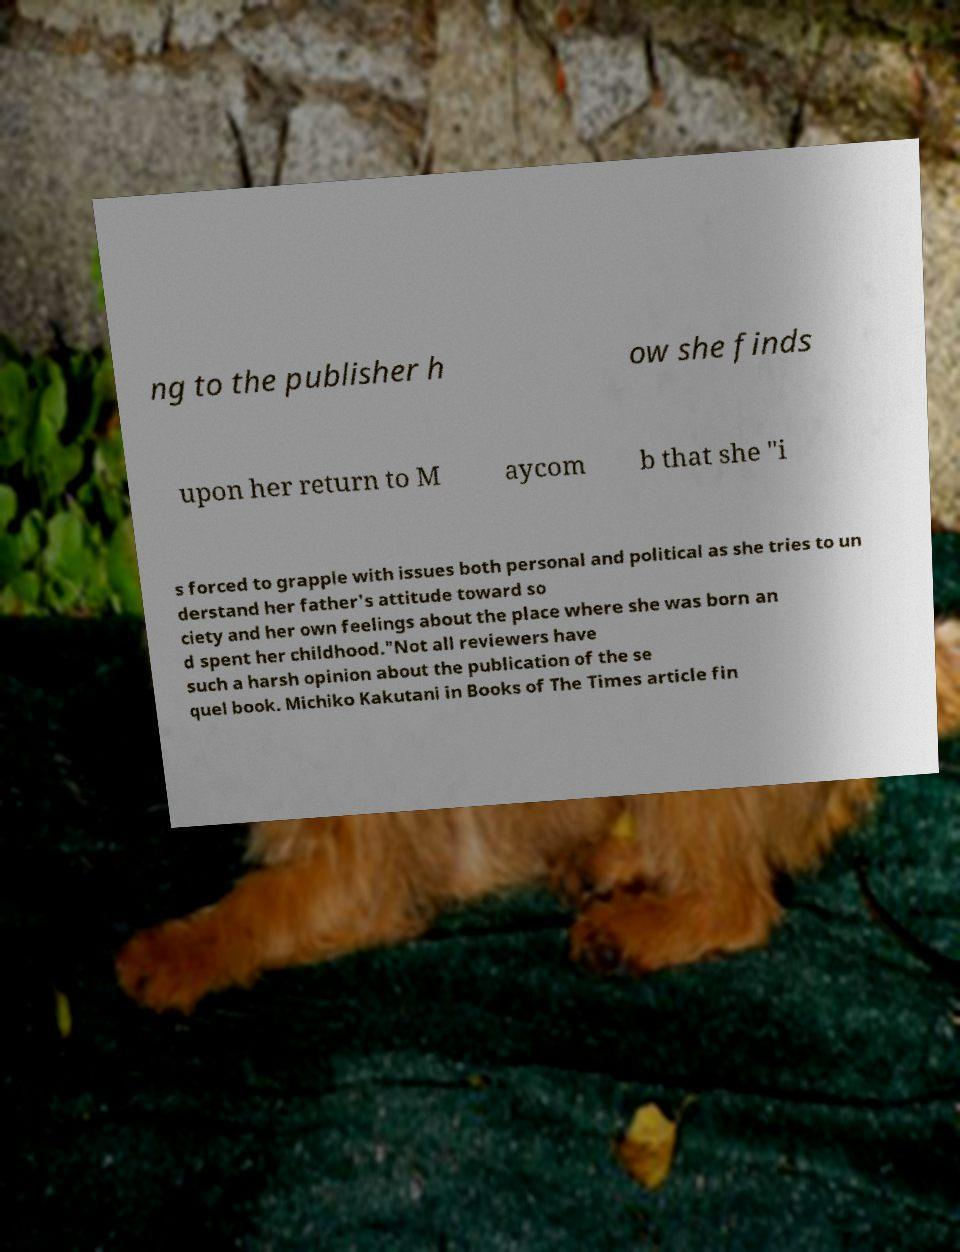I need the written content from this picture converted into text. Can you do that? ng to the publisher h ow she finds upon her return to M aycom b that she "i s forced to grapple with issues both personal and political as she tries to un derstand her father's attitude toward so ciety and her own feelings about the place where she was born an d spent her childhood."Not all reviewers have such a harsh opinion about the publication of the se quel book. Michiko Kakutani in Books of The Times article fin 